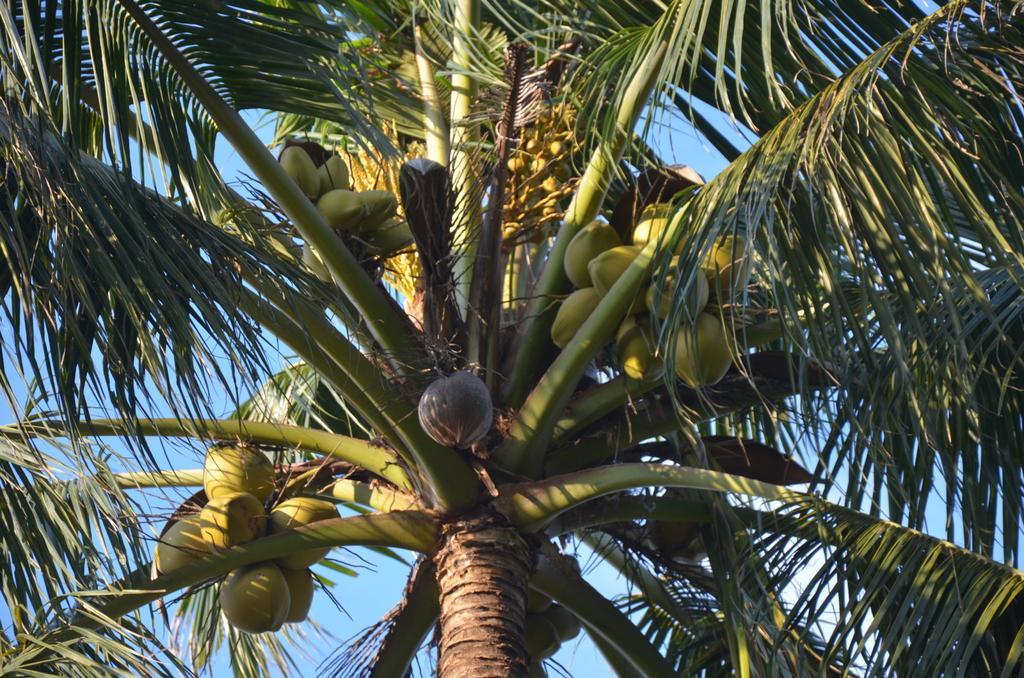Describe this image in one or two sentences. In this image I can see few coconuts to the tree. The sky is in blue color. 